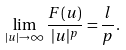<formula> <loc_0><loc_0><loc_500><loc_500>\lim _ { | u | \to \infty } \frac { F ( u ) } { | u | ^ { p } } = \frac { l } { p } .</formula> 